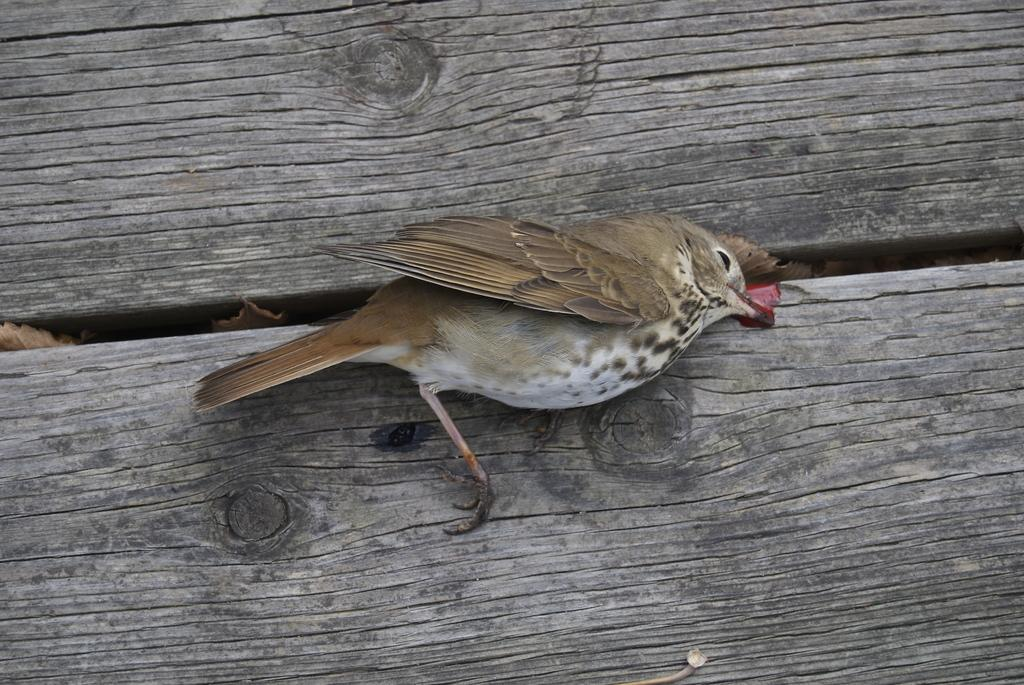What type of animal is present in the image? There is a bird in the image. Can you describe the surface on which the bird is situated? The bird is on a wooden surface. What type of ink can be seen on the bird's feathers in the image? There is no ink visible on the bird's feathers in the image. What might be the bird's attraction to the wooden surface in the image? The facts provided do not give any information about the bird's attraction to the wooden surface, so it cannot be determined from the image. 